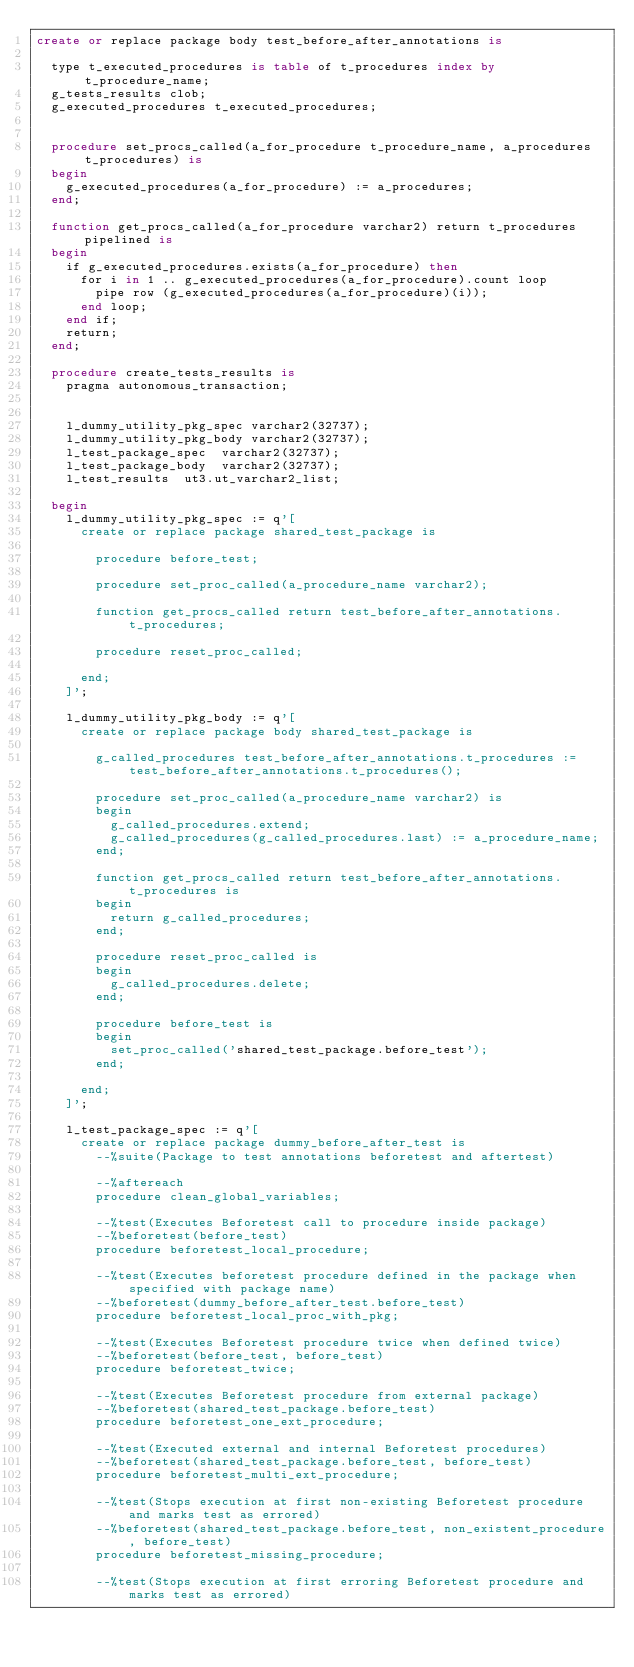<code> <loc_0><loc_0><loc_500><loc_500><_SQL_>create or replace package body test_before_after_annotations is

  type t_executed_procedures is table of t_procedures index by t_procedure_name;
  g_tests_results clob;
  g_executed_procedures t_executed_procedures;


  procedure set_procs_called(a_for_procedure t_procedure_name, a_procedures t_procedures) is
  begin
    g_executed_procedures(a_for_procedure) := a_procedures;
  end;

  function get_procs_called(a_for_procedure varchar2) return t_procedures pipelined is
  begin
    if g_executed_procedures.exists(a_for_procedure) then
      for i in 1 .. g_executed_procedures(a_for_procedure).count loop
        pipe row (g_executed_procedures(a_for_procedure)(i));
      end loop;
    end if;
    return;
  end;

  procedure create_tests_results is
    pragma autonomous_transaction;


    l_dummy_utility_pkg_spec varchar2(32737);
    l_dummy_utility_pkg_body varchar2(32737);
    l_test_package_spec  varchar2(32737);
    l_test_package_body  varchar2(32737);
    l_test_results  ut3.ut_varchar2_list;
    
  begin
    l_dummy_utility_pkg_spec := q'[
      create or replace package shared_test_package is

        procedure before_test;

        procedure set_proc_called(a_procedure_name varchar2);

        function get_procs_called return test_before_after_annotations.t_procedures;

        procedure reset_proc_called;

      end;
    ]';

    l_dummy_utility_pkg_body := q'[
      create or replace package body shared_test_package is

        g_called_procedures test_before_after_annotations.t_procedures := test_before_after_annotations.t_procedures();

        procedure set_proc_called(a_procedure_name varchar2) is
        begin
          g_called_procedures.extend;
          g_called_procedures(g_called_procedures.last) := a_procedure_name;
        end;

        function get_procs_called return test_before_after_annotations.t_procedures is
        begin
          return g_called_procedures;
        end;

        procedure reset_proc_called is
        begin
          g_called_procedures.delete;
        end;

        procedure before_test is
        begin
          set_proc_called('shared_test_package.before_test');
        end;

      end;
    ]';

    l_test_package_spec := q'[
      create or replace package dummy_before_after_test is
        --%suite(Package to test annotations beforetest and aftertest)

        --%aftereach
        procedure clean_global_variables;

        --%test(Executes Beforetest call to procedure inside package)
        --%beforetest(before_test)
        procedure beforetest_local_procedure;

        --%test(Executes beforetest procedure defined in the package when specified with package name)
        --%beforetest(dummy_before_after_test.before_test)
        procedure beforetest_local_proc_with_pkg;

        --%test(Executes Beforetest procedure twice when defined twice)
        --%beforetest(before_test, before_test)
        procedure beforetest_twice;

        --%test(Executes Beforetest procedure from external package)
        --%beforetest(shared_test_package.before_test)
        procedure beforetest_one_ext_procedure;

        --%test(Executed external and internal Beforetest procedures)
        --%beforetest(shared_test_package.before_test, before_test)
        procedure beforetest_multi_ext_procedure;

        --%test(Stops execution at first non-existing Beforetest procedure and marks test as errored)
        --%beforetest(shared_test_package.before_test, non_existent_procedure, before_test)
        procedure beforetest_missing_procedure;

        --%test(Stops execution at first erroring Beforetest procedure and marks test as errored)</code> 